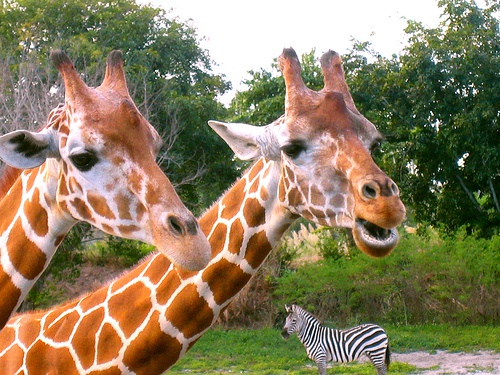Describe the objects in this image and their specific colors. I can see giraffe in olive, white, red, salmon, and brown tones, giraffe in olive, lavender, lightpink, and brown tones, and zebra in olive, lavender, gray, black, and darkgray tones in this image. 